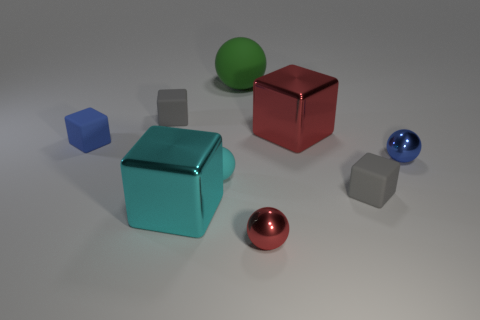How many gray blocks must be subtracted to get 1 gray blocks? 1 Subtract all green cylinders. How many gray cubes are left? 2 Subtract 1 balls. How many balls are left? 3 Subtract all tiny spheres. How many spheres are left? 1 Subtract all gray blocks. How many blocks are left? 3 Subtract all green balls. Subtract all yellow cylinders. How many balls are left? 3 Add 5 small cyan matte objects. How many small cyan matte objects are left? 6 Add 3 tiny cyan matte spheres. How many tiny cyan matte spheres exist? 4 Subtract 2 gray blocks. How many objects are left? 7 Subtract all cubes. How many objects are left? 4 